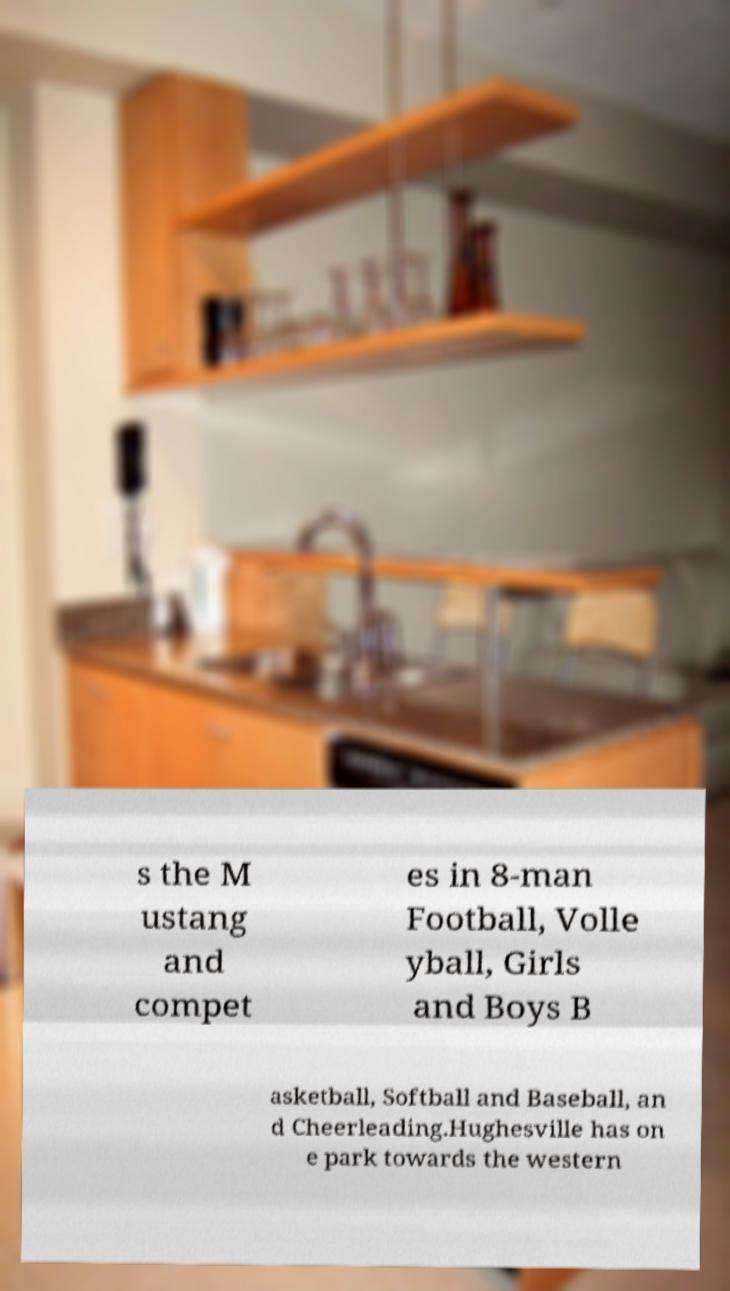I need the written content from this picture converted into text. Can you do that? s the M ustang and compet es in 8-man Football, Volle yball, Girls and Boys B asketball, Softball and Baseball, an d Cheerleading.Hughesville has on e park towards the western 